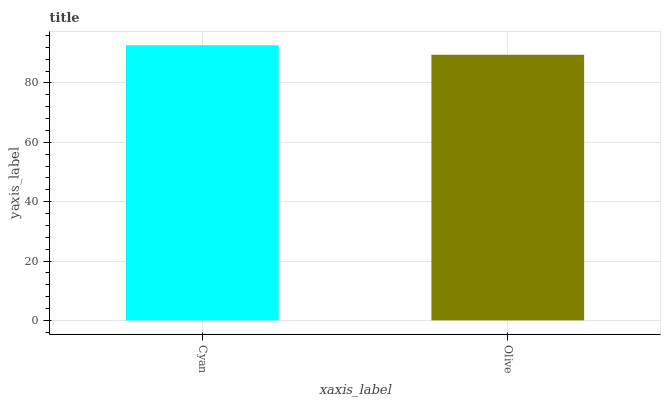Is Olive the minimum?
Answer yes or no. Yes. Is Cyan the maximum?
Answer yes or no. Yes. Is Olive the maximum?
Answer yes or no. No. Is Cyan greater than Olive?
Answer yes or no. Yes. Is Olive less than Cyan?
Answer yes or no. Yes. Is Olive greater than Cyan?
Answer yes or no. No. Is Cyan less than Olive?
Answer yes or no. No. Is Cyan the high median?
Answer yes or no. Yes. Is Olive the low median?
Answer yes or no. Yes. Is Olive the high median?
Answer yes or no. No. Is Cyan the low median?
Answer yes or no. No. 